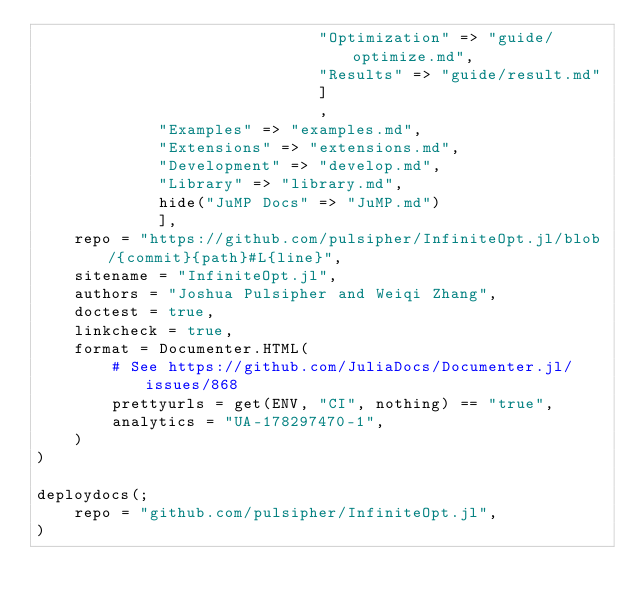Convert code to text. <code><loc_0><loc_0><loc_500><loc_500><_Julia_>                              "Optimization" => "guide/optimize.md",
                              "Results" => "guide/result.md"
                              ]
                              ,
             "Examples" => "examples.md",
             "Extensions" => "extensions.md",
             "Development" => "develop.md",
             "Library" => "library.md",
             hide("JuMP Docs" => "JuMP.md")
             ],
    repo = "https://github.com/pulsipher/InfiniteOpt.jl/blob/{commit}{path}#L{line}",
    sitename = "InfiniteOpt.jl",
    authors = "Joshua Pulsipher and Weiqi Zhang",
    doctest = true,
    linkcheck = true,
    format = Documenter.HTML(
        # See https://github.com/JuliaDocs/Documenter.jl/issues/868
        prettyurls = get(ENV, "CI", nothing) == "true",
        analytics = "UA-178297470-1",
    )
)

deploydocs(;
    repo = "github.com/pulsipher/InfiniteOpt.jl",
)

</code> 